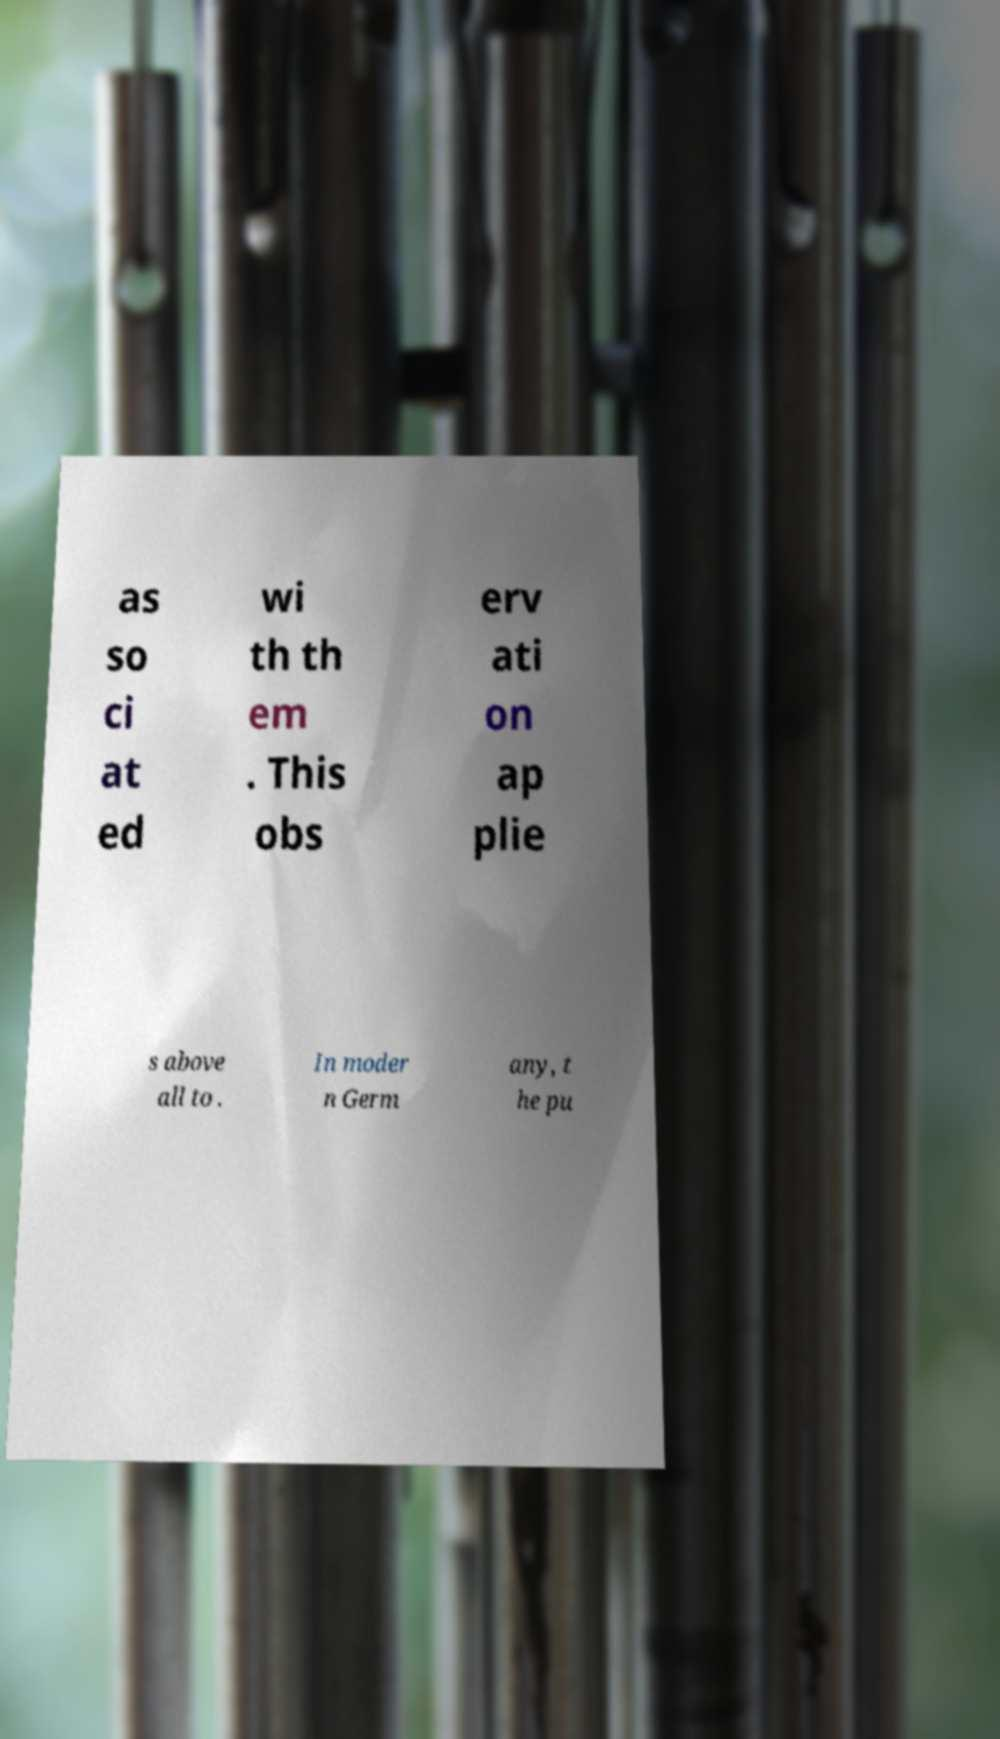Can you read and provide the text displayed in the image?This photo seems to have some interesting text. Can you extract and type it out for me? as so ci at ed wi th th em . This obs erv ati on ap plie s above all to . In moder n Germ any, t he pu 